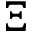<formula> <loc_0><loc_0><loc_500><loc_500>\Xi</formula> 